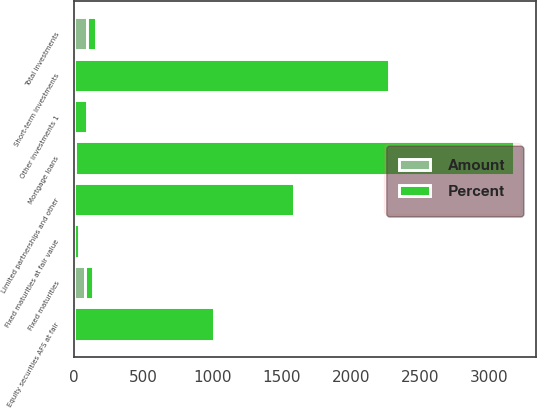Convert chart. <chart><loc_0><loc_0><loc_500><loc_500><stacked_bar_chart><ecel><fcel>Fixed maturities<fcel>Fixed maturities at fair value<fcel>Equity securities AFS at fair<fcel>Mortgage loans<fcel>Limited partnerships and other<fcel>Other investments 1<fcel>Short-term investments<fcel>Total investments<nl><fcel>Percent<fcel>61.45<fcel>41<fcel>1012<fcel>3175<fcel>1588<fcel>96<fcel>2270<fcel>61.45<nl><fcel>Amount<fcel>81.9<fcel>0.1<fcel>2.3<fcel>7<fcel>3.5<fcel>0.2<fcel>5<fcel>100<nl></chart> 